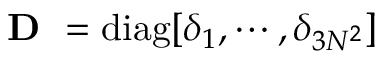Convert formula to latex. <formula><loc_0><loc_0><loc_500><loc_500>D = d i a g [ \delta _ { 1 } , \cdots , \delta _ { 3 N ^ { 2 } } ]</formula> 